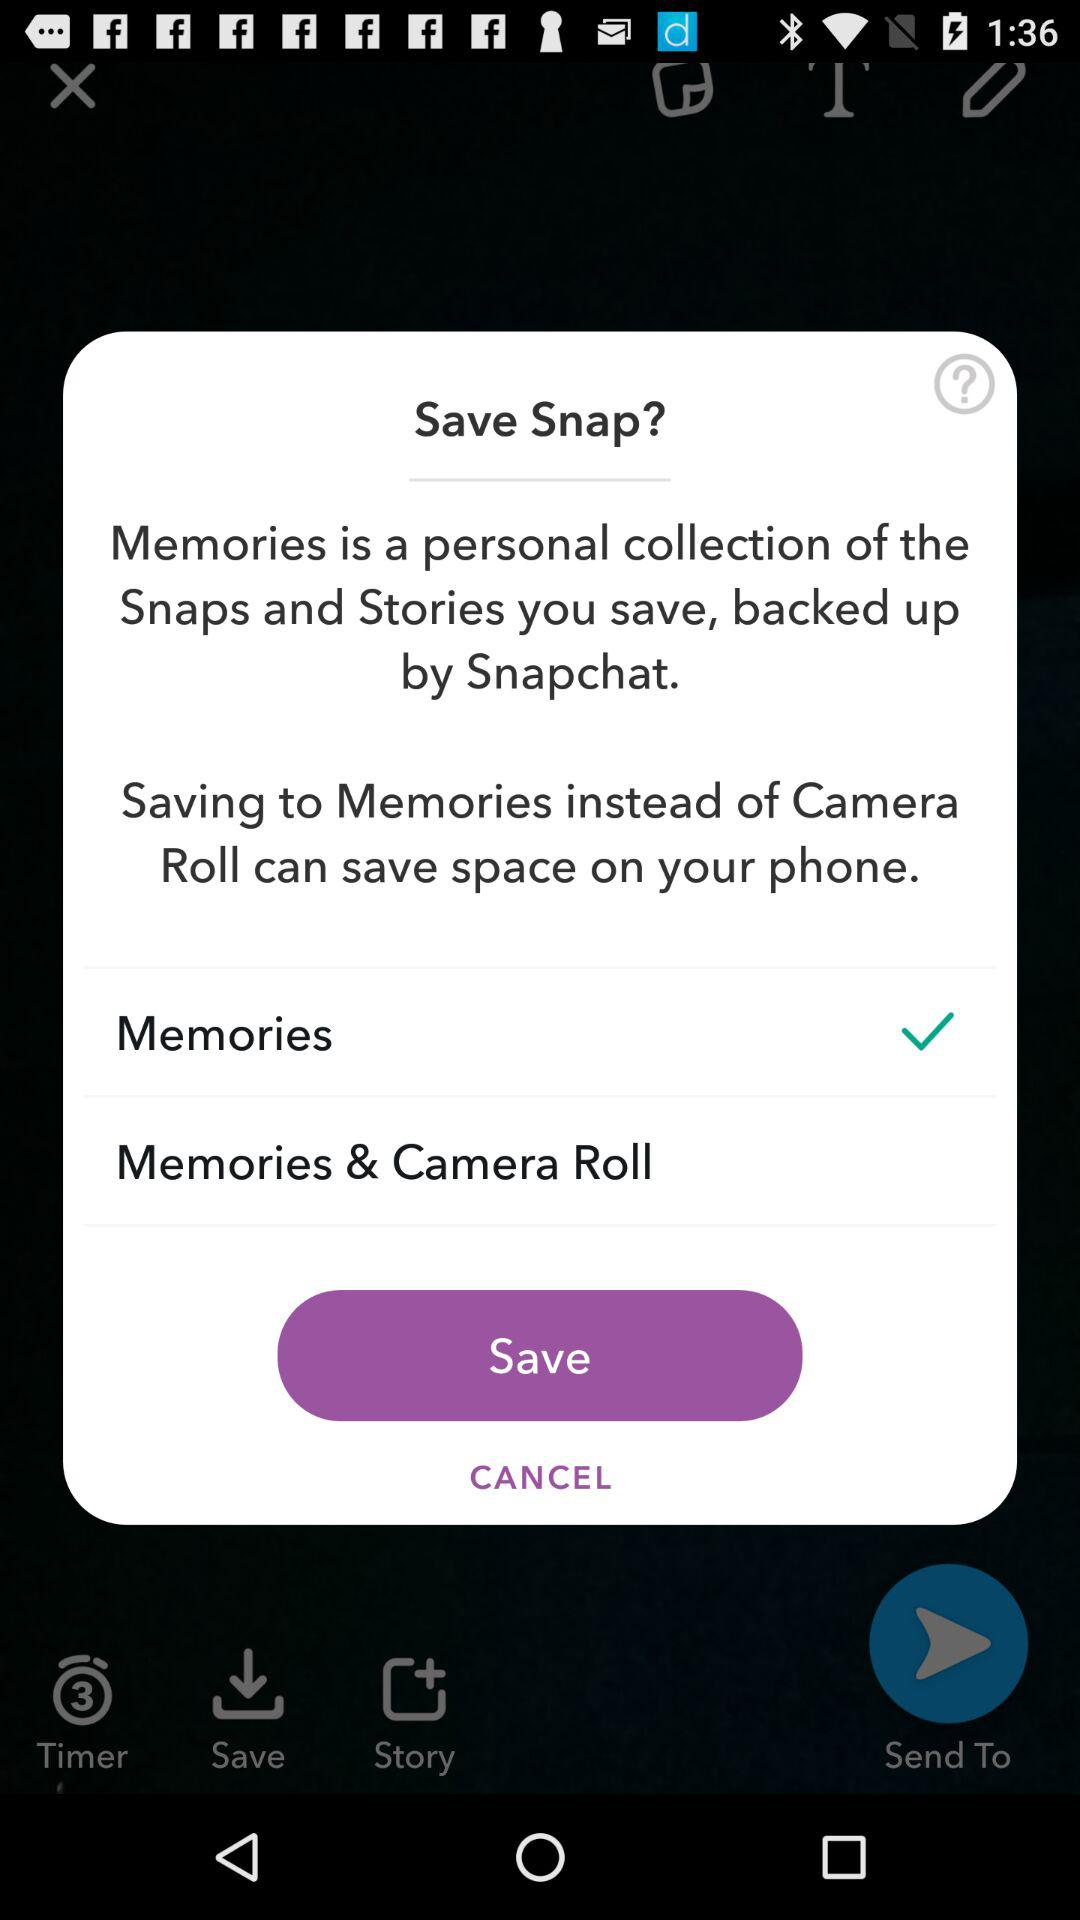How many places can I save my snap to?
Answer the question using a single word or phrase. 2 